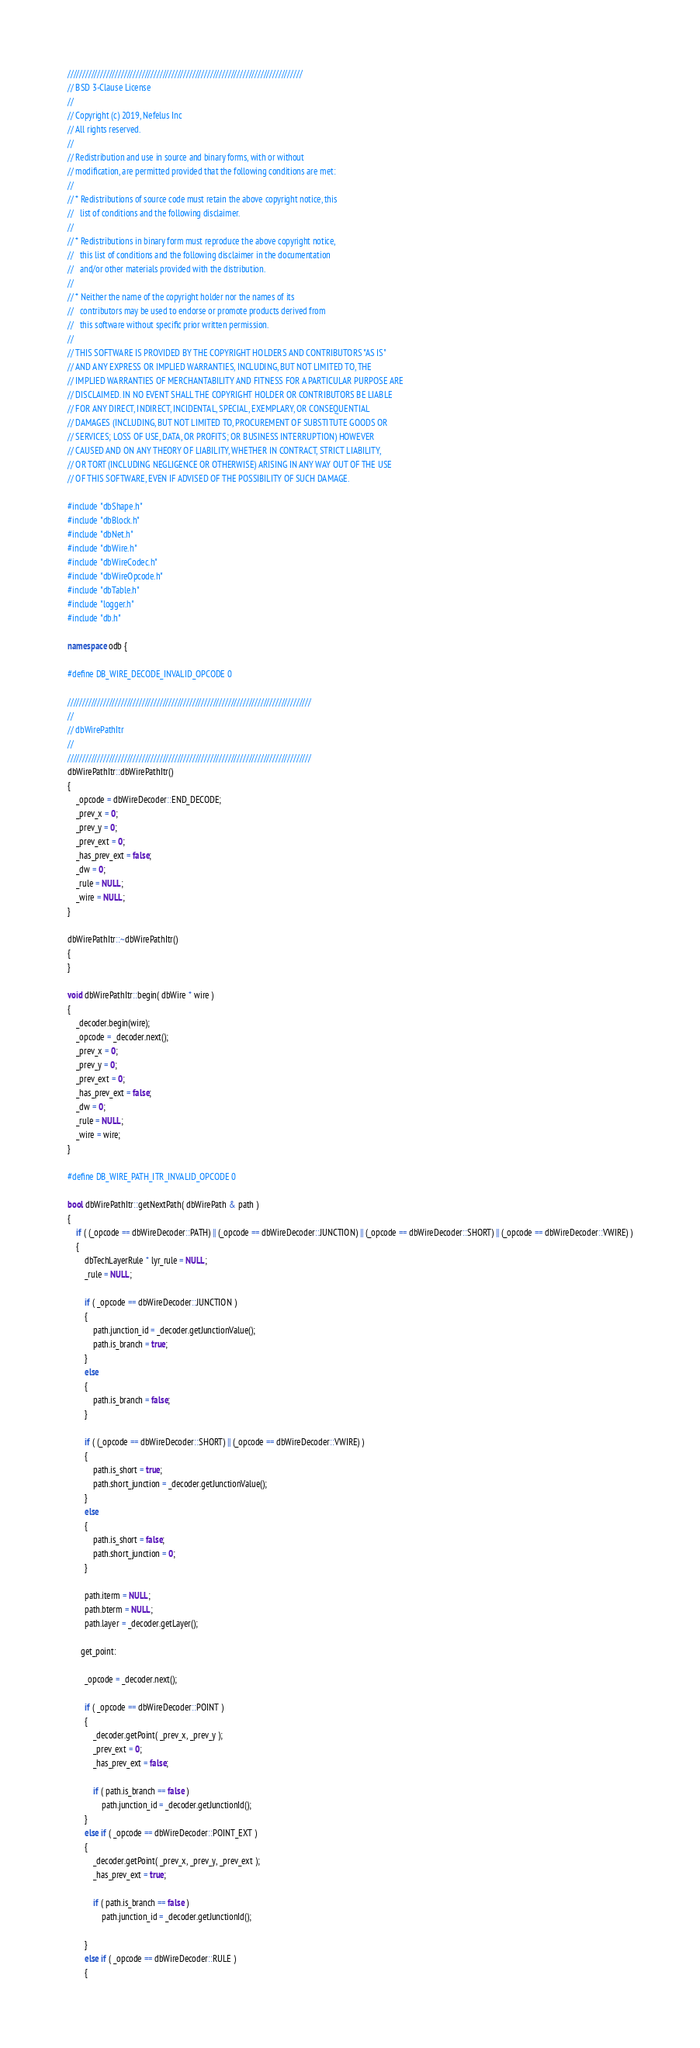<code> <loc_0><loc_0><loc_500><loc_500><_C++_>///////////////////////////////////////////////////////////////////////////////
// BSD 3-Clause License
//
// Copyright (c) 2019, Nefelus Inc
// All rights reserved.
//
// Redistribution and use in source and binary forms, with or without
// modification, are permitted provided that the following conditions are met:
//
// * Redistributions of source code must retain the above copyright notice, this
//   list of conditions and the following disclaimer.
//
// * Redistributions in binary form must reproduce the above copyright notice,
//   this list of conditions and the following disclaimer in the documentation
//   and/or other materials provided with the distribution.
//
// * Neither the name of the copyright holder nor the names of its
//   contributors may be used to endorse or promote products derived from
//   this software without specific prior written permission.
//
// THIS SOFTWARE IS PROVIDED BY THE COPYRIGHT HOLDERS AND CONTRIBUTORS "AS IS"
// AND ANY EXPRESS OR IMPLIED WARRANTIES, INCLUDING, BUT NOT LIMITED TO, THE
// IMPLIED WARRANTIES OF MERCHANTABILITY AND FITNESS FOR A PARTICULAR PURPOSE ARE
// DISCLAIMED. IN NO EVENT SHALL THE COPYRIGHT HOLDER OR CONTRIBUTORS BE LIABLE
// FOR ANY DIRECT, INDIRECT, INCIDENTAL, SPECIAL, EXEMPLARY, OR CONSEQUENTIAL
// DAMAGES (INCLUDING, BUT NOT LIMITED TO, PROCUREMENT OF SUBSTITUTE GOODS OR
// SERVICES; LOSS OF USE, DATA, OR PROFITS; OR BUSINESS INTERRUPTION) HOWEVER
// CAUSED AND ON ANY THEORY OF LIABILITY, WHETHER IN CONTRACT, STRICT LIABILITY,
// OR TORT (INCLUDING NEGLIGENCE OR OTHERWISE) ARISING IN ANY WAY OUT OF THE USE
// OF THIS SOFTWARE, EVEN IF ADVISED OF THE POSSIBILITY OF SUCH DAMAGE.

#include "dbShape.h"
#include "dbBlock.h"
#include "dbNet.h"
#include "dbWire.h"
#include "dbWireCodec.h"
#include "dbWireOpcode.h"
#include "dbTable.h"
#include "logger.h"
#include "db.h"

namespace odb {

#define DB_WIRE_DECODE_INVALID_OPCODE 0

//////////////////////////////////////////////////////////////////////////////////
//
// dbWirePathItr
//
//////////////////////////////////////////////////////////////////////////////////
dbWirePathItr::dbWirePathItr()
{
    _opcode = dbWireDecoder::END_DECODE;
    _prev_x = 0;
    _prev_y = 0;
    _prev_ext = 0;
    _has_prev_ext = false;
    _dw = 0;
    _rule = NULL;
    _wire = NULL;
}

dbWirePathItr::~dbWirePathItr()
{
}

void dbWirePathItr::begin( dbWire * wire )
{
    _decoder.begin(wire);
    _opcode = _decoder.next();
    _prev_x = 0;
    _prev_y = 0;
    _prev_ext = 0;
    _has_prev_ext = false;
    _dw = 0;
    _rule = NULL;
    _wire = wire;
}

#define DB_WIRE_PATH_ITR_INVALID_OPCODE 0

bool dbWirePathItr::getNextPath( dbWirePath & path )
{
    if ( (_opcode == dbWireDecoder::PATH) || (_opcode == dbWireDecoder::JUNCTION) || (_opcode == dbWireDecoder::SHORT) || (_opcode == dbWireDecoder::VWIRE) )
    {
        dbTechLayerRule * lyr_rule = NULL;
        _rule = NULL;
        
        if ( _opcode == dbWireDecoder::JUNCTION )
        {
            path.junction_id = _decoder.getJunctionValue();
            path.is_branch = true;
        }
        else
        {
            path.is_branch = false;
        }

        if ( (_opcode == dbWireDecoder::SHORT) || (_opcode == dbWireDecoder::VWIRE) )
        {
            path.is_short = true;
            path.short_junction = _decoder.getJunctionValue();
        }
        else
        {
            path.is_short = false;
            path.short_junction = 0;
        }
        
        path.iterm = NULL;
        path.bterm = NULL;
        path.layer = _decoder.getLayer();
        
      get_point:
        
        _opcode = _decoder.next();

        if ( _opcode == dbWireDecoder::POINT )
        {
            _decoder.getPoint( _prev_x, _prev_y );
            _prev_ext = 0;
            _has_prev_ext = false;

            if ( path.is_branch == false )
                path.junction_id = _decoder.getJunctionId();
        }
        else if ( _opcode == dbWireDecoder::POINT_EXT )
        {
            _decoder.getPoint( _prev_x, _prev_y, _prev_ext );
            _has_prev_ext = true;

            if ( path.is_branch == false )
                path.junction_id = _decoder.getJunctionId();

        }
        else if ( _opcode == dbWireDecoder::RULE )
        {</code> 